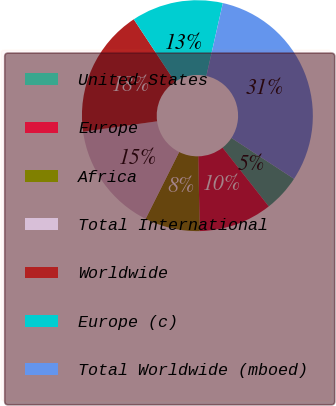Convert chart to OTSL. <chart><loc_0><loc_0><loc_500><loc_500><pie_chart><fcel>United States<fcel>Europe<fcel>Africa<fcel>Total International<fcel>Worldwide<fcel>Europe (c)<fcel>Total Worldwide (mboed)<nl><fcel>5.18%<fcel>10.28%<fcel>7.73%<fcel>15.38%<fcel>17.93%<fcel>12.83%<fcel>30.68%<nl></chart> 